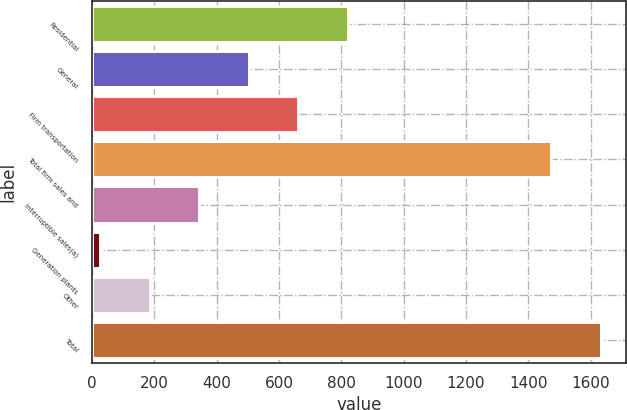<chart> <loc_0><loc_0><loc_500><loc_500><bar_chart><fcel>Residential<fcel>General<fcel>Firm transportation<fcel>Total firm sales and<fcel>Interruptible sales(a)<fcel>Generation plants<fcel>Other<fcel>Total<nl><fcel>821<fcel>503<fcel>662<fcel>1473<fcel>344<fcel>26<fcel>185<fcel>1632<nl></chart> 